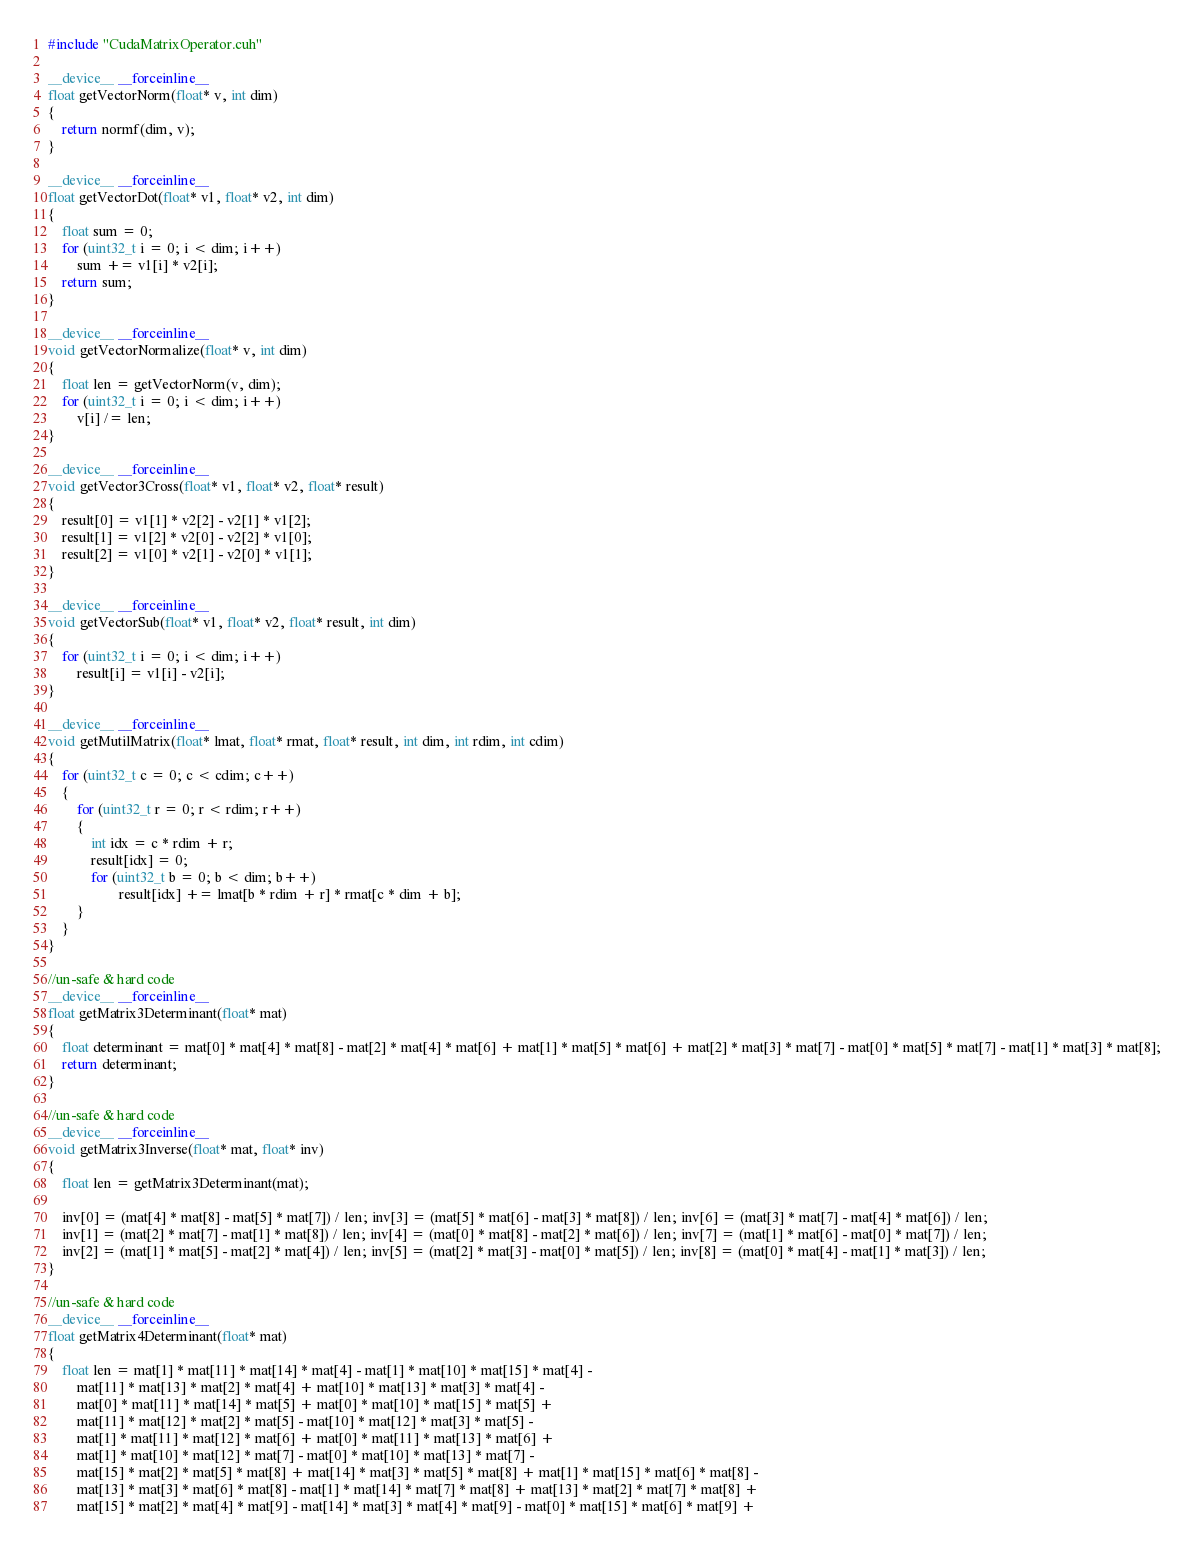Convert code to text. <code><loc_0><loc_0><loc_500><loc_500><_Cuda_>#include "CudaMatrixOperator.cuh"

__device__ __forceinline__
float getVectorNorm(float* v, int dim)
{
	return normf(dim, v);
}

__device__ __forceinline__
float getVectorDot(float* v1, float* v2, int dim)
{
	float sum = 0;
	for (uint32_t i = 0; i < dim; i++)
		sum += v1[i] * v2[i];
	return sum;
}

__device__ __forceinline__
void getVectorNormalize(float* v, int dim)
{
	float len = getVectorNorm(v, dim);
	for (uint32_t i = 0; i < dim; i++)
		v[i] /= len;
}

__device__ __forceinline__
void getVector3Cross(float* v1, float* v2, float* result)
{
	result[0] = v1[1] * v2[2] - v2[1] * v1[2];
	result[1] = v1[2] * v2[0] - v2[2] * v1[0];
	result[2] = v1[0] * v2[1] - v2[0] * v1[1];
}

__device__ __forceinline__
void getVectorSub(float* v1, float* v2, float* result, int dim)
{
	for (uint32_t i = 0; i < dim; i++)
		result[i] = v1[i] - v2[i];
}

__device__ __forceinline__
void getMutilMatrix(float* lmat, float* rmat, float* result, int dim, int rdim, int cdim)
{
	for (uint32_t c = 0; c < cdim; c++)
	{
		for (uint32_t r = 0; r < rdim; r++)
		{
			int idx = c * rdim + r;
			result[idx] = 0;
			for (uint32_t b = 0; b < dim; b++)
					result[idx] += lmat[b * rdim + r] * rmat[c * dim + b];
		}
	}
}

//un-safe & hard code
__device__ __forceinline__
float getMatrix3Determinant(float* mat)
{
	float determinant = mat[0] * mat[4] * mat[8] - mat[2] * mat[4] * mat[6] + mat[1] * mat[5] * mat[6] + mat[2] * mat[3] * mat[7] - mat[0] * mat[5] * mat[7] - mat[1] * mat[3] * mat[8];
	return determinant;
}

//un-safe & hard code
__device__ __forceinline__
void getMatrix3Inverse(float* mat, float* inv)
{
	float len = getMatrix3Determinant(mat);

	inv[0] = (mat[4] * mat[8] - mat[5] * mat[7]) / len; inv[3] = (mat[5] * mat[6] - mat[3] * mat[8]) / len; inv[6] = (mat[3] * mat[7] - mat[4] * mat[6]) / len;
	inv[1] = (mat[2] * mat[7] - mat[1] * mat[8]) / len; inv[4] = (mat[0] * mat[8] - mat[2] * mat[6]) / len; inv[7] = (mat[1] * mat[6] - mat[0] * mat[7]) / len;
	inv[2] = (mat[1] * mat[5] - mat[2] * mat[4]) / len; inv[5] = (mat[2] * mat[3] - mat[0] * mat[5]) / len; inv[8] = (mat[0] * mat[4] - mat[1] * mat[3]) / len;
}

//un-safe & hard code
__device__ __forceinline__
float getMatrix4Determinant(float* mat)
{
	float len = mat[1] * mat[11] * mat[14] * mat[4] - mat[1] * mat[10] * mat[15] * mat[4] -
		mat[11] * mat[13] * mat[2] * mat[4] + mat[10] * mat[13] * mat[3] * mat[4] -
		mat[0] * mat[11] * mat[14] * mat[5] + mat[0] * mat[10] * mat[15] * mat[5] +
		mat[11] * mat[12] * mat[2] * mat[5] - mat[10] * mat[12] * mat[3] * mat[5] -
		mat[1] * mat[11] * mat[12] * mat[6] + mat[0] * mat[11] * mat[13] * mat[6] +
		mat[1] * mat[10] * mat[12] * mat[7] - mat[0] * mat[10] * mat[13] * mat[7] -
		mat[15] * mat[2] * mat[5] * mat[8] + mat[14] * mat[3] * mat[5] * mat[8] + mat[1] * mat[15] * mat[6] * mat[8] -
		mat[13] * mat[3] * mat[6] * mat[8] - mat[1] * mat[14] * mat[7] * mat[8] + mat[13] * mat[2] * mat[7] * mat[8] +
		mat[15] * mat[2] * mat[4] * mat[9] - mat[14] * mat[3] * mat[4] * mat[9] - mat[0] * mat[15] * mat[6] * mat[9] +</code> 